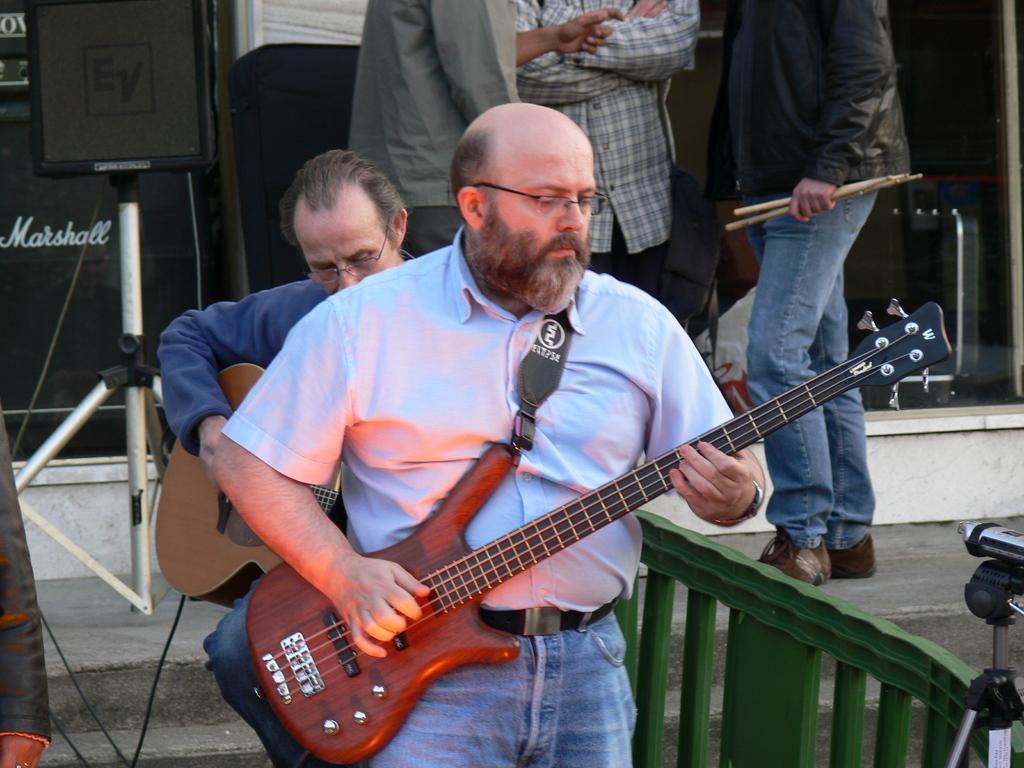Please provide a concise description of this image. a person is standing and playing guitar. behind him another person is playing guitar. behind them there are 3 people standing. 